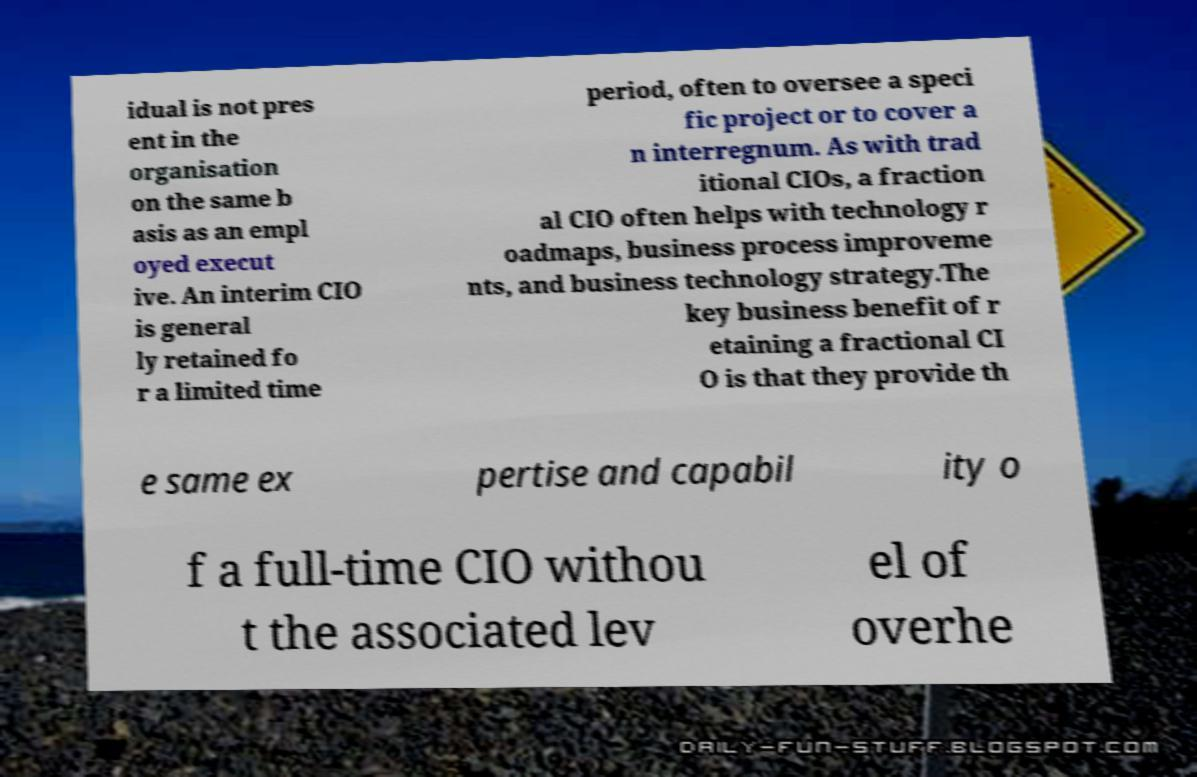There's text embedded in this image that I need extracted. Can you transcribe it verbatim? idual is not pres ent in the organisation on the same b asis as an empl oyed execut ive. An interim CIO is general ly retained fo r a limited time period, often to oversee a speci fic project or to cover a n interregnum. As with trad itional CIOs, a fraction al CIO often helps with technology r oadmaps, business process improveme nts, and business technology strategy.The key business benefit of r etaining a fractional CI O is that they provide th e same ex pertise and capabil ity o f a full-time CIO withou t the associated lev el of overhe 